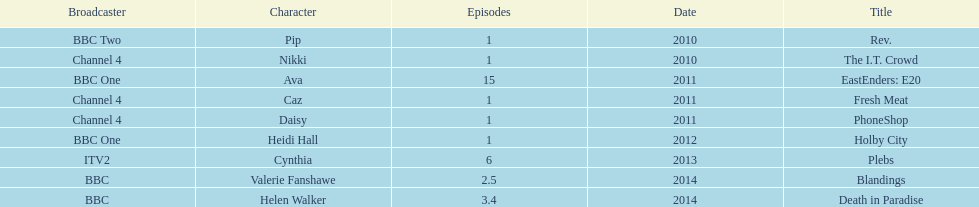What was the previous role this actress played before playing cynthia in plebs? Heidi Hall. 